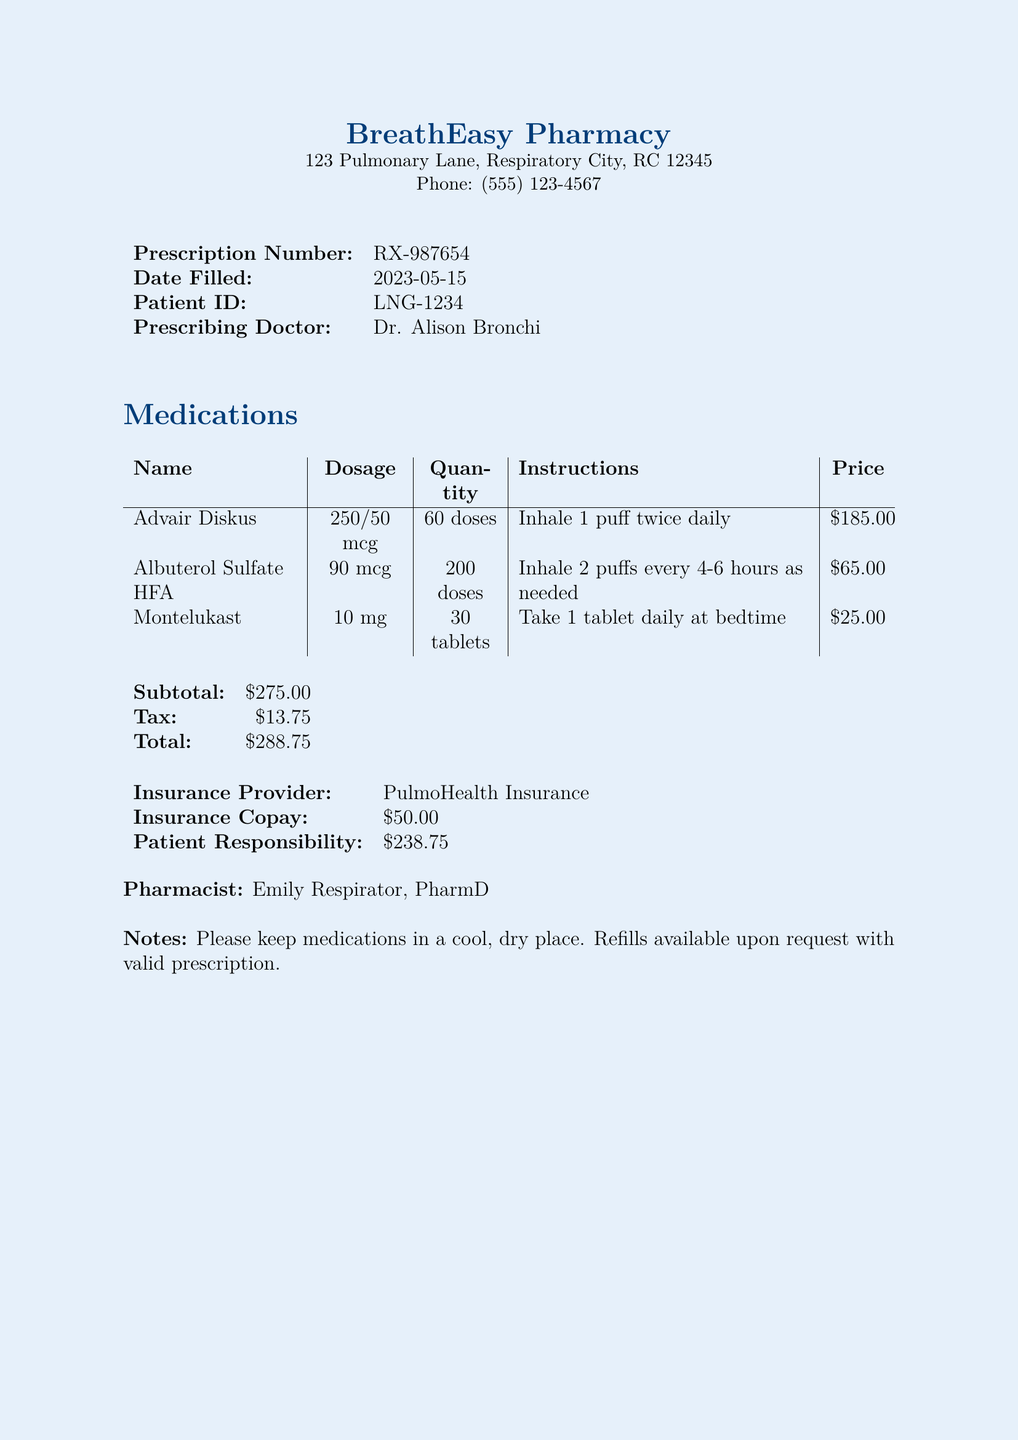What is the prescription number? The prescription number is listed under the relevant heading in the document.
Answer: RX-987654 Who is the prescribing doctor? The prescribing doctor's name is included in the patient information section of the document.
Answer: Dr. Alison Bronchi What is the total amount billed? The total amount is calculated from the subtotal and tax in the billing section.
Answer: $288.75 How much is the copay? The copay is specified under the insurance details in the document.
Answer: $50.00 What medication has the highest price? By comparing the prices listed, the medication with the highest cost can be identified.
Answer: Advair Diskus How many doses of Albuterol Sulfate HFA are included? The quantity is noted next to the medication name in the table of medications.
Answer: 200 doses What is the patient’s responsibility after insurance? The patient's responsibility is detailed in the insurance section of the document.
Answer: $238.75 What instructions are given for Montelukast? The instructions for each medication are provided in the medication table.
Answer: Take 1 tablet daily at bedtime How many doses does Advair Diskus contain? This information can be extracted from the dosage details provided in the medications table.
Answer: 60 doses 